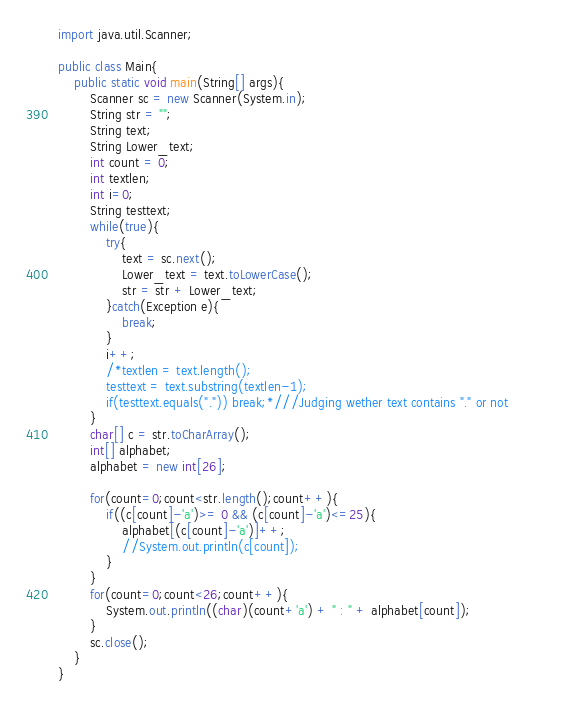Convert code to text. <code><loc_0><loc_0><loc_500><loc_500><_Java_>import java.util.Scanner;

public class Main{
    public static void main(String[] args){
        Scanner sc = new Scanner(System.in);
        String str = "";  
        String text;
        String Lower_text;
        int count = 0;
        int textlen;
        int i=0;
        String testtext;        
        while(true){
            try{
                text = sc.next();
                Lower_text = text.toLowerCase();
                str = str + Lower_text;
            }catch(Exception e){
                break;
            }        
            i++;
            /*textlen = text.length();
            testtext = text.substring(textlen-1);
            if(testtext.equals(".")) break;*///Judging wether text contains "." or not            
        }
        char[] c = str.toCharArray();
        int[] alphabet;
        alphabet = new int[26];
        
        for(count=0;count<str.length();count++){
            if((c[count]-'a')>= 0 && (c[count]-'a')<=25){
                alphabet[(c[count]-'a')]++;
                //System.out.println(c[count]);
            }            
        }
        for(count=0;count<26;count++){
            System.out.println((char)(count+'a') + " : " + alphabet[count]);
        }
        sc.close();
    }
}
</code> 